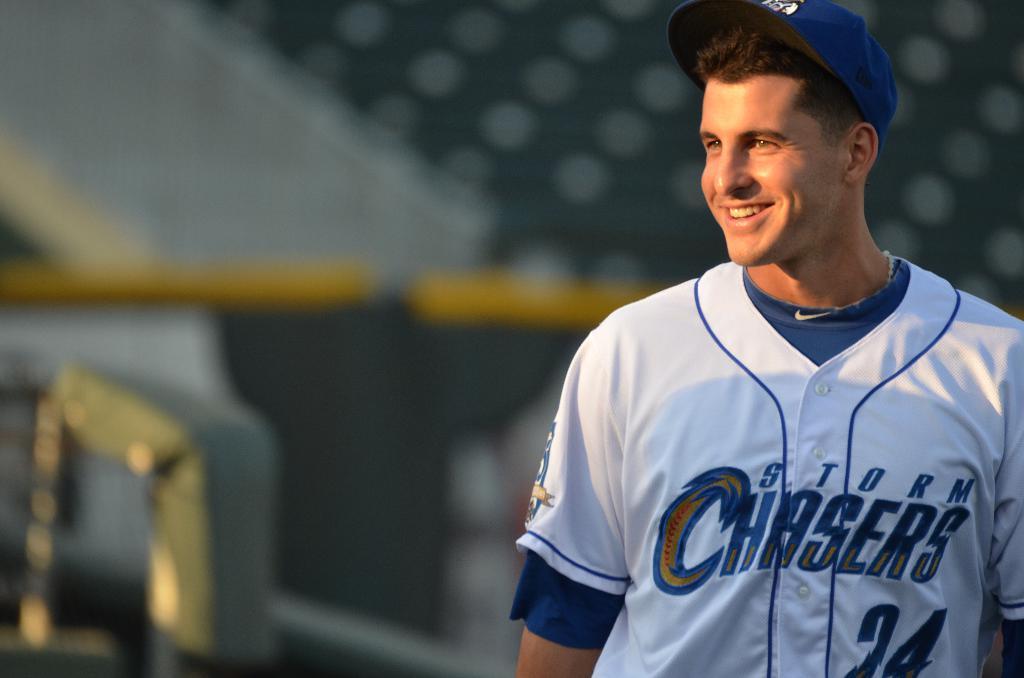What team does this player play for?
Keep it short and to the point. Storm chasers. What is the player number?
Give a very brief answer. 24. 